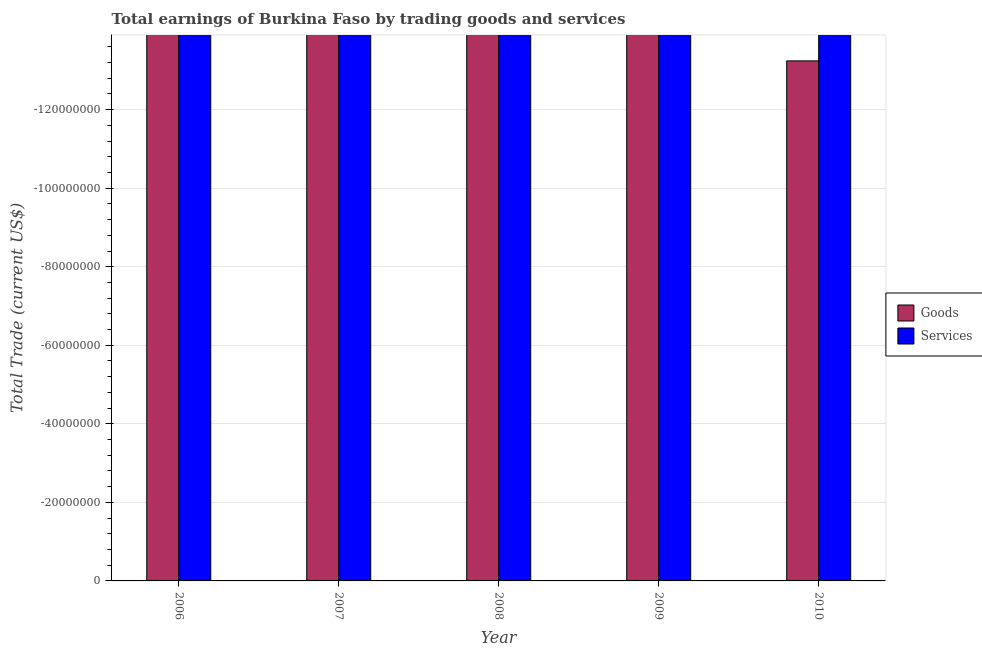How many different coloured bars are there?
Give a very brief answer. 0. Are the number of bars on each tick of the X-axis equal?
Your response must be concise. Yes. How many bars are there on the 1st tick from the left?
Your response must be concise. 0. How many bars are there on the 2nd tick from the right?
Your answer should be compact. 0. What is the label of the 5th group of bars from the left?
Provide a succinct answer. 2010. In how many cases, is the number of bars for a given year not equal to the number of legend labels?
Provide a succinct answer. 5. What is the total amount earned by trading services in the graph?
Make the answer very short. 0. What is the difference between the amount earned by trading goods in 2010 and the amount earned by trading services in 2007?
Make the answer very short. 0. In how many years, is the amount earned by trading services greater than -36000000 US$?
Provide a succinct answer. 0. In how many years, is the amount earned by trading goods greater than the average amount earned by trading goods taken over all years?
Offer a very short reply. 0. How many bars are there?
Your answer should be compact. 0. Are the values on the major ticks of Y-axis written in scientific E-notation?
Your answer should be compact. No. Does the graph contain grids?
Provide a succinct answer. Yes. What is the title of the graph?
Give a very brief answer. Total earnings of Burkina Faso by trading goods and services. Does "Imports" appear as one of the legend labels in the graph?
Offer a very short reply. No. What is the label or title of the X-axis?
Your answer should be very brief. Year. What is the label or title of the Y-axis?
Offer a terse response. Total Trade (current US$). What is the Total Trade (current US$) of Goods in 2006?
Provide a short and direct response. 0. What is the Total Trade (current US$) of Services in 2006?
Your answer should be compact. 0. What is the Total Trade (current US$) in Goods in 2007?
Offer a very short reply. 0. What is the Total Trade (current US$) in Goods in 2008?
Your answer should be very brief. 0. What is the Total Trade (current US$) of Services in 2008?
Make the answer very short. 0. What is the Total Trade (current US$) in Goods in 2009?
Provide a succinct answer. 0. What is the Total Trade (current US$) in Services in 2009?
Your answer should be very brief. 0. What is the average Total Trade (current US$) of Services per year?
Your answer should be compact. 0. 